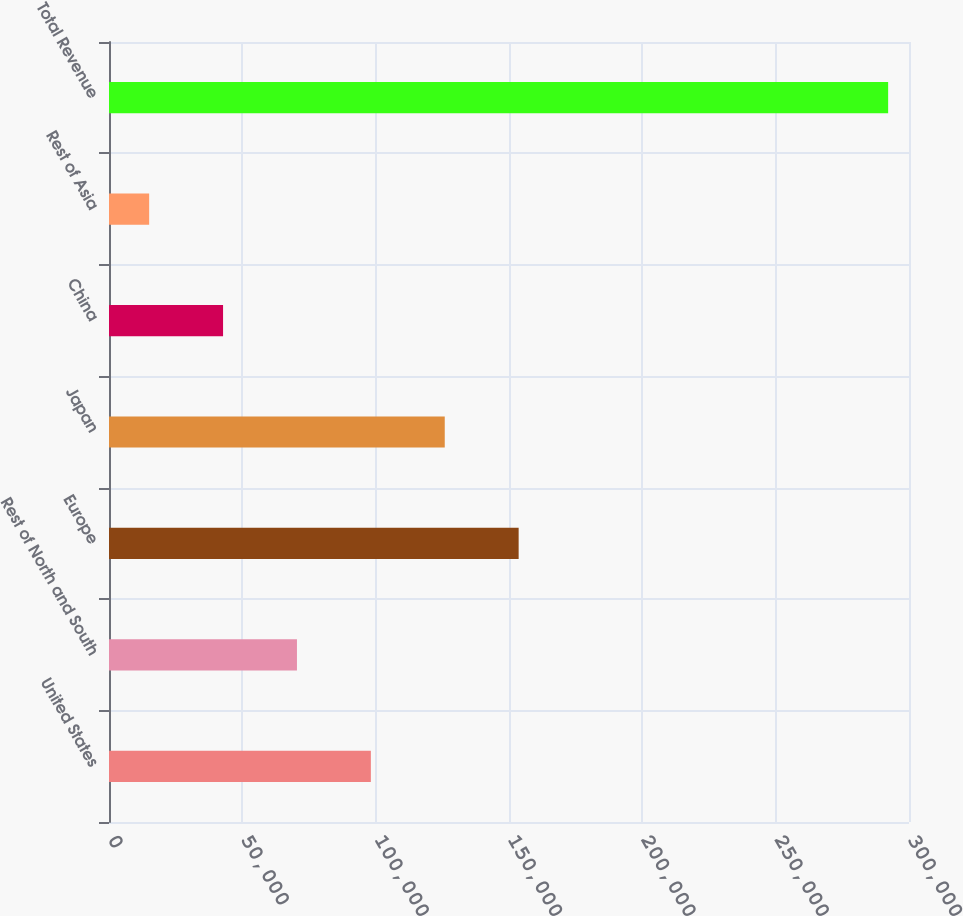Convert chart. <chart><loc_0><loc_0><loc_500><loc_500><bar_chart><fcel>United States<fcel>Rest of North and South<fcel>Europe<fcel>Japan<fcel>China<fcel>Rest of Asia<fcel>Total Revenue<nl><fcel>98196.1<fcel>70484.4<fcel>153620<fcel>125908<fcel>42772.7<fcel>15061<fcel>292178<nl></chart> 